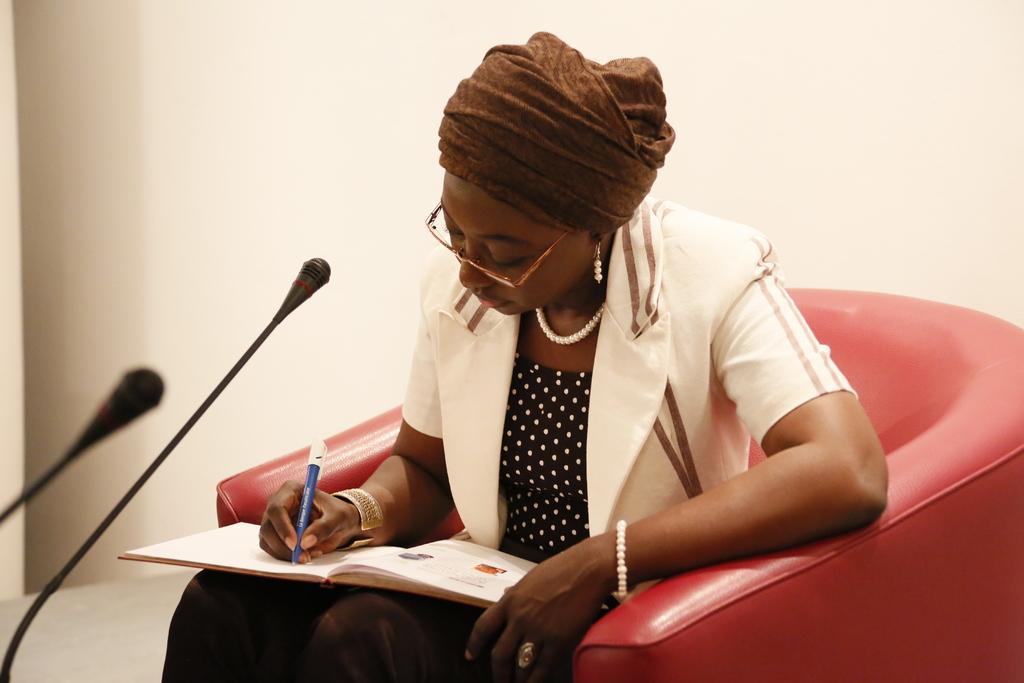In one or two sentences, can you explain what this image depicts? The woman in the middle of the picture wearing a black dress and white coat is holding a pen in her hand and she is writing something on the book and she is sitting on the red color chair. In front of her, we see microphones and behind her, we see a white wall. This picture is clicked in a room. 